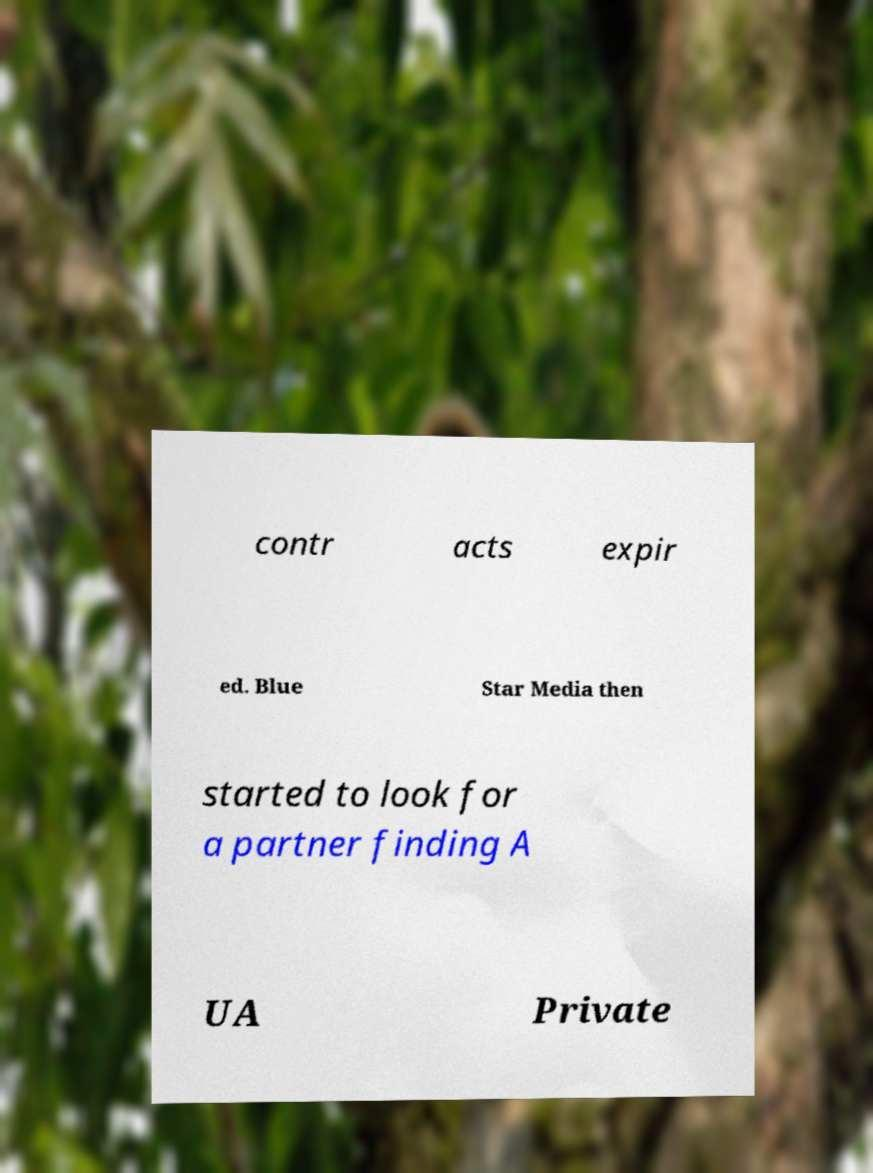Could you assist in decoding the text presented in this image and type it out clearly? contr acts expir ed. Blue Star Media then started to look for a partner finding A UA Private 